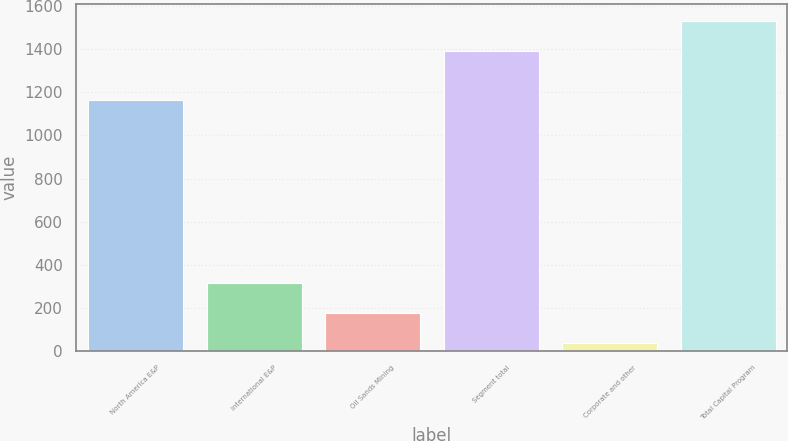<chart> <loc_0><loc_0><loc_500><loc_500><bar_chart><fcel>North America E&P<fcel>International E&P<fcel>Oil Sands Mining<fcel>Segment total<fcel>Corporate and other<fcel>Total Capital Program<nl><fcel>1166<fcel>318.4<fcel>179.2<fcel>1392<fcel>40<fcel>1531.2<nl></chart> 